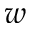<formula> <loc_0><loc_0><loc_500><loc_500>w</formula> 